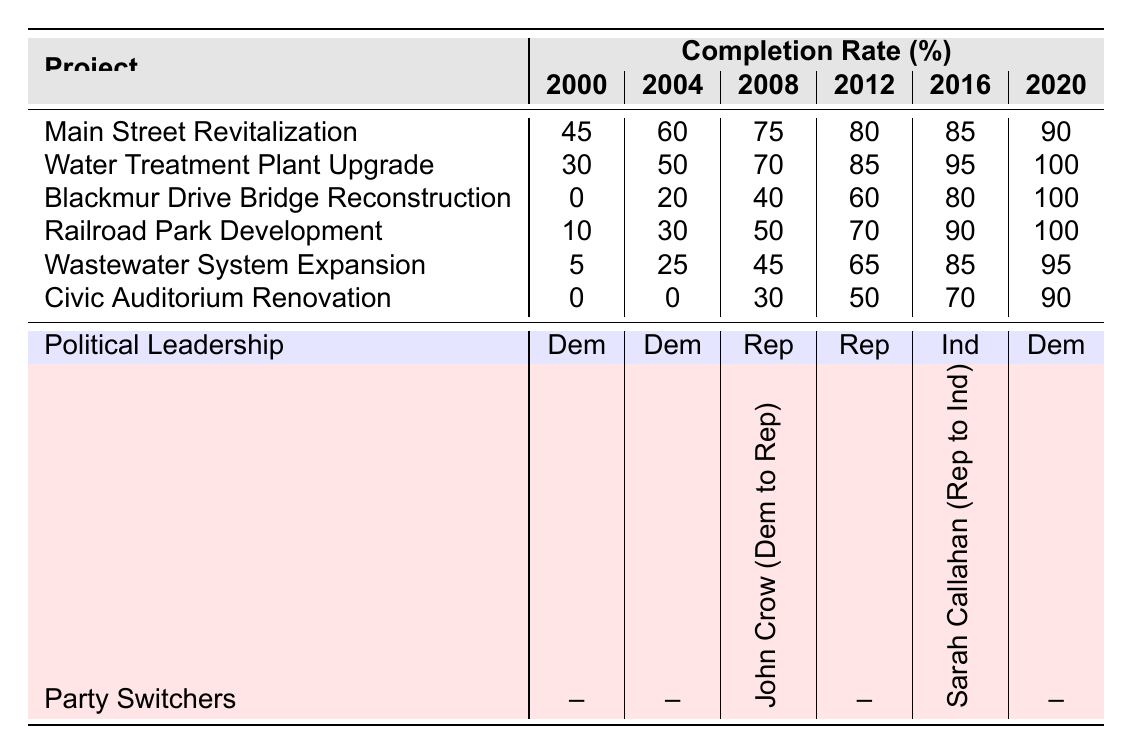What was the completion rate of the Water Treatment Plant Upgrade in 2012? The table shows the completion rate for the Water Treatment Plant Upgrade in 2012 is 85%.
Answer: 85% Which project had the highest completion rate in 2020? In 2020, the project with the highest completion rate is the Water Treatment Plant Upgrade, with a rate of 100%.
Answer: Water Treatment Plant Upgrade Was there a project that reached 100% completion during the 2016 political leadership? By looking at the table, in 2016, no project reached 100% completion since the highest rate was the Civic Auditorium Renovation at 70%.
Answer: No What project showed the most significant improvement from 2000 to 2020? The Blackmur Drive Bridge Reconstruction improved from 0% in 2000 to 100% in 2020, showing the most significant improvement of 100 percentage points.
Answer: Blackmur Drive Bridge Reconstruction What is the average completion rate of the Main Street Revitalization project from 2000 to 2020? To find the average, sum the rates from each year: (45 + 60 + 75 + 80 + 85 + 90) = 435. There are 6 years, so the average is 435 / 6 = 72.5.
Answer: 72.5 Did the completion rate of the Wastewater System Expansion increase every year? The rates for the Wastewater System Expansion are 5, 25, 45, 65, 85, and 95. Since each subsequent rate is higher than the previous one, it did increase every year.
Answer: Yes How many projects had a completion rate of at least 90% in 2020? In 2020, three projects had completion rates of 90% or higher: Water Treatment Plant Upgrade (100%), Blackmur Drive Bridge Reconstruction (100%), and Railroad Park Development (100%).
Answer: 3 What was the political leadership between 2008 and 2012 and how did it affect the completion rates of the projects? The political leadership shifted from Republican (2008) to Republican (2012). During these years, several projects showed an upward trend in completion rates, suggesting consistent support for infrastructure from that leadership.
Answer: Republican What is the total completion rate of the Civic Auditorium Renovation across the years? The completion rates for the Civic Auditorium Renovation are 0, 0, 30, 50, 70, and 90. Summing these gives 0 + 0 + 30 + 50 + 70 + 90 = 240, the total completion rate across the years is 240.
Answer: 240 Was the transition from Republican to Independent leadership in 2016 associated with higher project completion rates in Water Valley? The completion rates in 2016 were a mix; however, there was a relatively high completion at 70% or above for two projects. The data doesn't show a consistent rise due to the leadership change alone.
Answer: No 